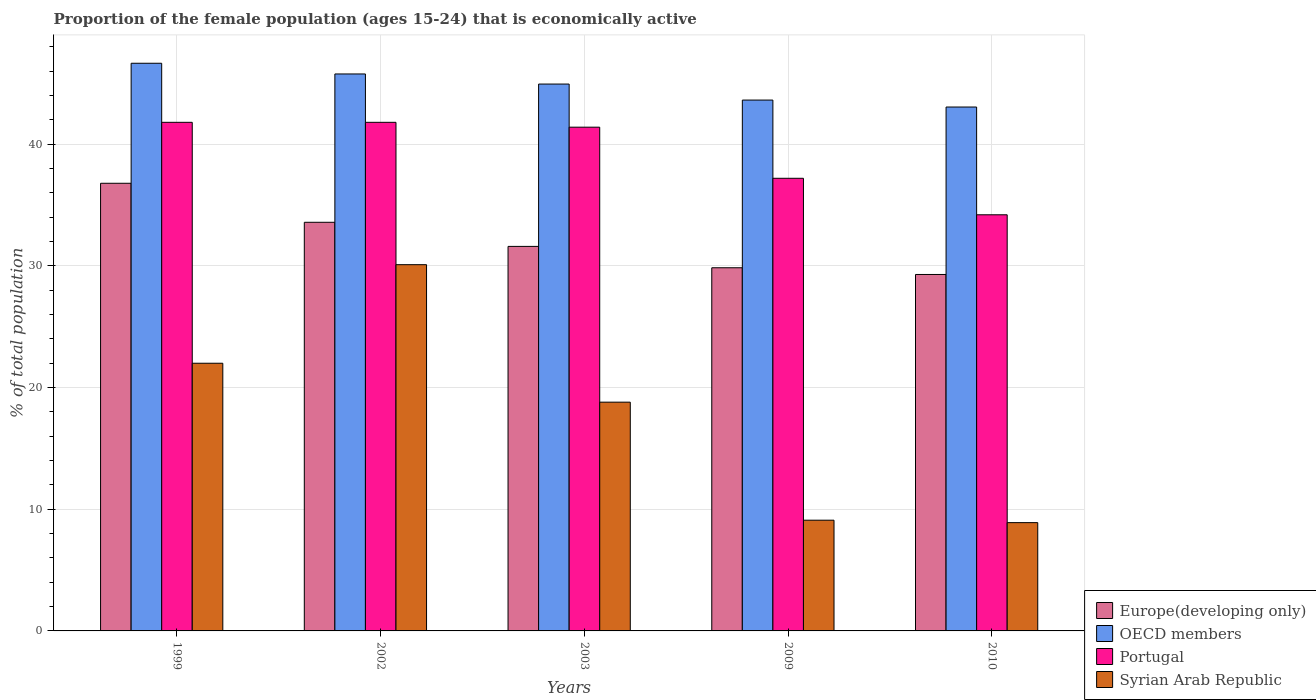How many different coloured bars are there?
Ensure brevity in your answer.  4. Are the number of bars per tick equal to the number of legend labels?
Give a very brief answer. Yes. How many bars are there on the 1st tick from the left?
Make the answer very short. 4. What is the proportion of the female population that is economically active in Syrian Arab Republic in 2003?
Your answer should be very brief. 18.8. Across all years, what is the maximum proportion of the female population that is economically active in OECD members?
Offer a terse response. 46.65. Across all years, what is the minimum proportion of the female population that is economically active in Syrian Arab Republic?
Make the answer very short. 8.9. In which year was the proportion of the female population that is economically active in Syrian Arab Republic maximum?
Your answer should be very brief. 2002. In which year was the proportion of the female population that is economically active in Europe(developing only) minimum?
Ensure brevity in your answer.  2010. What is the total proportion of the female population that is economically active in OECD members in the graph?
Offer a terse response. 224.06. What is the difference between the proportion of the female population that is economically active in OECD members in 2003 and that in 2010?
Make the answer very short. 1.89. What is the difference between the proportion of the female population that is economically active in Portugal in 2003 and the proportion of the female population that is economically active in Syrian Arab Republic in 2009?
Make the answer very short. 32.3. What is the average proportion of the female population that is economically active in OECD members per year?
Provide a succinct answer. 44.81. In the year 2003, what is the difference between the proportion of the female population that is economically active in Europe(developing only) and proportion of the female population that is economically active in OECD members?
Offer a very short reply. -13.34. What is the ratio of the proportion of the female population that is economically active in OECD members in 1999 to that in 2003?
Provide a succinct answer. 1.04. Is the difference between the proportion of the female population that is economically active in Europe(developing only) in 2002 and 2009 greater than the difference between the proportion of the female population that is economically active in OECD members in 2002 and 2009?
Ensure brevity in your answer.  Yes. What is the difference between the highest and the second highest proportion of the female population that is economically active in OECD members?
Offer a very short reply. 0.88. What is the difference between the highest and the lowest proportion of the female population that is economically active in OECD members?
Your answer should be compact. 3.6. In how many years, is the proportion of the female population that is economically active in Syrian Arab Republic greater than the average proportion of the female population that is economically active in Syrian Arab Republic taken over all years?
Provide a short and direct response. 3. What does the 4th bar from the right in 2010 represents?
Offer a very short reply. Europe(developing only). How many bars are there?
Keep it short and to the point. 20. Are all the bars in the graph horizontal?
Your answer should be compact. No. Are the values on the major ticks of Y-axis written in scientific E-notation?
Keep it short and to the point. No. What is the title of the graph?
Your answer should be compact. Proportion of the female population (ages 15-24) that is economically active. What is the label or title of the Y-axis?
Your response must be concise. % of total population. What is the % of total population of Europe(developing only) in 1999?
Give a very brief answer. 36.79. What is the % of total population of OECD members in 1999?
Keep it short and to the point. 46.65. What is the % of total population in Portugal in 1999?
Offer a terse response. 41.8. What is the % of total population in Europe(developing only) in 2002?
Ensure brevity in your answer.  33.58. What is the % of total population in OECD members in 2002?
Provide a succinct answer. 45.77. What is the % of total population in Portugal in 2002?
Provide a succinct answer. 41.8. What is the % of total population of Syrian Arab Republic in 2002?
Offer a very short reply. 30.1. What is the % of total population of Europe(developing only) in 2003?
Give a very brief answer. 31.6. What is the % of total population of OECD members in 2003?
Your answer should be compact. 44.94. What is the % of total population in Portugal in 2003?
Keep it short and to the point. 41.4. What is the % of total population of Syrian Arab Republic in 2003?
Your answer should be very brief. 18.8. What is the % of total population in Europe(developing only) in 2009?
Provide a succinct answer. 29.85. What is the % of total population in OECD members in 2009?
Keep it short and to the point. 43.63. What is the % of total population of Portugal in 2009?
Your answer should be compact. 37.2. What is the % of total population of Syrian Arab Republic in 2009?
Provide a short and direct response. 9.1. What is the % of total population in Europe(developing only) in 2010?
Keep it short and to the point. 29.29. What is the % of total population of OECD members in 2010?
Provide a short and direct response. 43.06. What is the % of total population in Portugal in 2010?
Provide a succinct answer. 34.2. What is the % of total population in Syrian Arab Republic in 2010?
Provide a short and direct response. 8.9. Across all years, what is the maximum % of total population of Europe(developing only)?
Offer a very short reply. 36.79. Across all years, what is the maximum % of total population of OECD members?
Provide a succinct answer. 46.65. Across all years, what is the maximum % of total population of Portugal?
Offer a terse response. 41.8. Across all years, what is the maximum % of total population of Syrian Arab Republic?
Make the answer very short. 30.1. Across all years, what is the minimum % of total population of Europe(developing only)?
Give a very brief answer. 29.29. Across all years, what is the minimum % of total population of OECD members?
Provide a succinct answer. 43.06. Across all years, what is the minimum % of total population in Portugal?
Provide a short and direct response. 34.2. Across all years, what is the minimum % of total population of Syrian Arab Republic?
Ensure brevity in your answer.  8.9. What is the total % of total population in Europe(developing only) in the graph?
Provide a short and direct response. 161.12. What is the total % of total population in OECD members in the graph?
Keep it short and to the point. 224.06. What is the total % of total population in Portugal in the graph?
Keep it short and to the point. 196.4. What is the total % of total population in Syrian Arab Republic in the graph?
Your answer should be compact. 88.9. What is the difference between the % of total population in Europe(developing only) in 1999 and that in 2002?
Give a very brief answer. 3.21. What is the difference between the % of total population in OECD members in 1999 and that in 2002?
Your answer should be compact. 0.88. What is the difference between the % of total population in Portugal in 1999 and that in 2002?
Your answer should be compact. 0. What is the difference between the % of total population of Syrian Arab Republic in 1999 and that in 2002?
Keep it short and to the point. -8.1. What is the difference between the % of total population of Europe(developing only) in 1999 and that in 2003?
Provide a succinct answer. 5.19. What is the difference between the % of total population in OECD members in 1999 and that in 2003?
Your response must be concise. 1.71. What is the difference between the % of total population of Europe(developing only) in 1999 and that in 2009?
Give a very brief answer. 6.94. What is the difference between the % of total population of OECD members in 1999 and that in 2009?
Make the answer very short. 3.03. What is the difference between the % of total population in Portugal in 1999 and that in 2009?
Your answer should be compact. 4.6. What is the difference between the % of total population of Europe(developing only) in 1999 and that in 2010?
Offer a terse response. 7.5. What is the difference between the % of total population of OECD members in 1999 and that in 2010?
Your answer should be very brief. 3.6. What is the difference between the % of total population in Syrian Arab Republic in 1999 and that in 2010?
Keep it short and to the point. 13.1. What is the difference between the % of total population of Europe(developing only) in 2002 and that in 2003?
Your answer should be compact. 1.98. What is the difference between the % of total population in OECD members in 2002 and that in 2003?
Your response must be concise. 0.83. What is the difference between the % of total population in Portugal in 2002 and that in 2003?
Provide a short and direct response. 0.4. What is the difference between the % of total population in Syrian Arab Republic in 2002 and that in 2003?
Offer a terse response. 11.3. What is the difference between the % of total population of Europe(developing only) in 2002 and that in 2009?
Offer a terse response. 3.74. What is the difference between the % of total population of OECD members in 2002 and that in 2009?
Keep it short and to the point. 2.15. What is the difference between the % of total population in Portugal in 2002 and that in 2009?
Your response must be concise. 4.6. What is the difference between the % of total population in Europe(developing only) in 2002 and that in 2010?
Keep it short and to the point. 4.29. What is the difference between the % of total population in OECD members in 2002 and that in 2010?
Ensure brevity in your answer.  2.72. What is the difference between the % of total population of Portugal in 2002 and that in 2010?
Make the answer very short. 7.6. What is the difference between the % of total population in Syrian Arab Republic in 2002 and that in 2010?
Your response must be concise. 21.2. What is the difference between the % of total population in Europe(developing only) in 2003 and that in 2009?
Keep it short and to the point. 1.76. What is the difference between the % of total population in OECD members in 2003 and that in 2009?
Your answer should be very brief. 1.32. What is the difference between the % of total population of Portugal in 2003 and that in 2009?
Provide a short and direct response. 4.2. What is the difference between the % of total population of Syrian Arab Republic in 2003 and that in 2009?
Give a very brief answer. 9.7. What is the difference between the % of total population in Europe(developing only) in 2003 and that in 2010?
Offer a terse response. 2.31. What is the difference between the % of total population in OECD members in 2003 and that in 2010?
Give a very brief answer. 1.89. What is the difference between the % of total population in Europe(developing only) in 2009 and that in 2010?
Keep it short and to the point. 0.55. What is the difference between the % of total population of OECD members in 2009 and that in 2010?
Your answer should be very brief. 0.57. What is the difference between the % of total population in Syrian Arab Republic in 2009 and that in 2010?
Offer a very short reply. 0.2. What is the difference between the % of total population in Europe(developing only) in 1999 and the % of total population in OECD members in 2002?
Offer a terse response. -8.98. What is the difference between the % of total population in Europe(developing only) in 1999 and the % of total population in Portugal in 2002?
Your answer should be very brief. -5.01. What is the difference between the % of total population of Europe(developing only) in 1999 and the % of total population of Syrian Arab Republic in 2002?
Provide a succinct answer. 6.69. What is the difference between the % of total population in OECD members in 1999 and the % of total population in Portugal in 2002?
Your answer should be very brief. 4.85. What is the difference between the % of total population of OECD members in 1999 and the % of total population of Syrian Arab Republic in 2002?
Keep it short and to the point. 16.55. What is the difference between the % of total population of Europe(developing only) in 1999 and the % of total population of OECD members in 2003?
Your answer should be very brief. -8.15. What is the difference between the % of total population in Europe(developing only) in 1999 and the % of total population in Portugal in 2003?
Give a very brief answer. -4.61. What is the difference between the % of total population of Europe(developing only) in 1999 and the % of total population of Syrian Arab Republic in 2003?
Your response must be concise. 17.99. What is the difference between the % of total population in OECD members in 1999 and the % of total population in Portugal in 2003?
Make the answer very short. 5.25. What is the difference between the % of total population in OECD members in 1999 and the % of total population in Syrian Arab Republic in 2003?
Your answer should be compact. 27.85. What is the difference between the % of total population of Europe(developing only) in 1999 and the % of total population of OECD members in 2009?
Give a very brief answer. -6.84. What is the difference between the % of total population of Europe(developing only) in 1999 and the % of total population of Portugal in 2009?
Your answer should be very brief. -0.41. What is the difference between the % of total population of Europe(developing only) in 1999 and the % of total population of Syrian Arab Republic in 2009?
Offer a terse response. 27.69. What is the difference between the % of total population of OECD members in 1999 and the % of total population of Portugal in 2009?
Your answer should be compact. 9.45. What is the difference between the % of total population in OECD members in 1999 and the % of total population in Syrian Arab Republic in 2009?
Give a very brief answer. 37.55. What is the difference between the % of total population in Portugal in 1999 and the % of total population in Syrian Arab Republic in 2009?
Offer a terse response. 32.7. What is the difference between the % of total population in Europe(developing only) in 1999 and the % of total population in OECD members in 2010?
Make the answer very short. -6.27. What is the difference between the % of total population in Europe(developing only) in 1999 and the % of total population in Portugal in 2010?
Your response must be concise. 2.59. What is the difference between the % of total population of Europe(developing only) in 1999 and the % of total population of Syrian Arab Republic in 2010?
Make the answer very short. 27.89. What is the difference between the % of total population in OECD members in 1999 and the % of total population in Portugal in 2010?
Your answer should be compact. 12.45. What is the difference between the % of total population in OECD members in 1999 and the % of total population in Syrian Arab Republic in 2010?
Provide a succinct answer. 37.75. What is the difference between the % of total population of Portugal in 1999 and the % of total population of Syrian Arab Republic in 2010?
Your response must be concise. 32.9. What is the difference between the % of total population in Europe(developing only) in 2002 and the % of total population in OECD members in 2003?
Ensure brevity in your answer.  -11.36. What is the difference between the % of total population of Europe(developing only) in 2002 and the % of total population of Portugal in 2003?
Make the answer very short. -7.82. What is the difference between the % of total population in Europe(developing only) in 2002 and the % of total population in Syrian Arab Republic in 2003?
Offer a very short reply. 14.78. What is the difference between the % of total population of OECD members in 2002 and the % of total population of Portugal in 2003?
Your response must be concise. 4.37. What is the difference between the % of total population in OECD members in 2002 and the % of total population in Syrian Arab Republic in 2003?
Ensure brevity in your answer.  26.97. What is the difference between the % of total population of Portugal in 2002 and the % of total population of Syrian Arab Republic in 2003?
Your answer should be very brief. 23. What is the difference between the % of total population of Europe(developing only) in 2002 and the % of total population of OECD members in 2009?
Offer a terse response. -10.04. What is the difference between the % of total population in Europe(developing only) in 2002 and the % of total population in Portugal in 2009?
Your response must be concise. -3.62. What is the difference between the % of total population of Europe(developing only) in 2002 and the % of total population of Syrian Arab Republic in 2009?
Ensure brevity in your answer.  24.48. What is the difference between the % of total population of OECD members in 2002 and the % of total population of Portugal in 2009?
Offer a terse response. 8.57. What is the difference between the % of total population in OECD members in 2002 and the % of total population in Syrian Arab Republic in 2009?
Give a very brief answer. 36.67. What is the difference between the % of total population in Portugal in 2002 and the % of total population in Syrian Arab Republic in 2009?
Your answer should be very brief. 32.7. What is the difference between the % of total population of Europe(developing only) in 2002 and the % of total population of OECD members in 2010?
Ensure brevity in your answer.  -9.47. What is the difference between the % of total population of Europe(developing only) in 2002 and the % of total population of Portugal in 2010?
Your response must be concise. -0.62. What is the difference between the % of total population of Europe(developing only) in 2002 and the % of total population of Syrian Arab Republic in 2010?
Make the answer very short. 24.68. What is the difference between the % of total population in OECD members in 2002 and the % of total population in Portugal in 2010?
Keep it short and to the point. 11.57. What is the difference between the % of total population of OECD members in 2002 and the % of total population of Syrian Arab Republic in 2010?
Your answer should be compact. 36.87. What is the difference between the % of total population in Portugal in 2002 and the % of total population in Syrian Arab Republic in 2010?
Offer a terse response. 32.9. What is the difference between the % of total population in Europe(developing only) in 2003 and the % of total population in OECD members in 2009?
Give a very brief answer. -12.03. What is the difference between the % of total population of Europe(developing only) in 2003 and the % of total population of Portugal in 2009?
Offer a terse response. -5.6. What is the difference between the % of total population of Europe(developing only) in 2003 and the % of total population of Syrian Arab Republic in 2009?
Provide a succinct answer. 22.5. What is the difference between the % of total population of OECD members in 2003 and the % of total population of Portugal in 2009?
Your answer should be very brief. 7.74. What is the difference between the % of total population of OECD members in 2003 and the % of total population of Syrian Arab Republic in 2009?
Provide a succinct answer. 35.84. What is the difference between the % of total population of Portugal in 2003 and the % of total population of Syrian Arab Republic in 2009?
Give a very brief answer. 32.3. What is the difference between the % of total population of Europe(developing only) in 2003 and the % of total population of OECD members in 2010?
Ensure brevity in your answer.  -11.45. What is the difference between the % of total population in Europe(developing only) in 2003 and the % of total population in Portugal in 2010?
Ensure brevity in your answer.  -2.6. What is the difference between the % of total population in Europe(developing only) in 2003 and the % of total population in Syrian Arab Republic in 2010?
Offer a terse response. 22.7. What is the difference between the % of total population of OECD members in 2003 and the % of total population of Portugal in 2010?
Make the answer very short. 10.74. What is the difference between the % of total population in OECD members in 2003 and the % of total population in Syrian Arab Republic in 2010?
Offer a terse response. 36.04. What is the difference between the % of total population in Portugal in 2003 and the % of total population in Syrian Arab Republic in 2010?
Keep it short and to the point. 32.5. What is the difference between the % of total population in Europe(developing only) in 2009 and the % of total population in OECD members in 2010?
Provide a succinct answer. -13.21. What is the difference between the % of total population in Europe(developing only) in 2009 and the % of total population in Portugal in 2010?
Make the answer very short. -4.35. What is the difference between the % of total population in Europe(developing only) in 2009 and the % of total population in Syrian Arab Republic in 2010?
Offer a terse response. 20.95. What is the difference between the % of total population of OECD members in 2009 and the % of total population of Portugal in 2010?
Offer a terse response. 9.43. What is the difference between the % of total population in OECD members in 2009 and the % of total population in Syrian Arab Republic in 2010?
Keep it short and to the point. 34.73. What is the difference between the % of total population of Portugal in 2009 and the % of total population of Syrian Arab Republic in 2010?
Ensure brevity in your answer.  28.3. What is the average % of total population of Europe(developing only) per year?
Your response must be concise. 32.22. What is the average % of total population of OECD members per year?
Your answer should be very brief. 44.81. What is the average % of total population in Portugal per year?
Keep it short and to the point. 39.28. What is the average % of total population in Syrian Arab Republic per year?
Offer a terse response. 17.78. In the year 1999, what is the difference between the % of total population of Europe(developing only) and % of total population of OECD members?
Give a very brief answer. -9.86. In the year 1999, what is the difference between the % of total population of Europe(developing only) and % of total population of Portugal?
Your answer should be compact. -5.01. In the year 1999, what is the difference between the % of total population of Europe(developing only) and % of total population of Syrian Arab Republic?
Give a very brief answer. 14.79. In the year 1999, what is the difference between the % of total population of OECD members and % of total population of Portugal?
Your response must be concise. 4.85. In the year 1999, what is the difference between the % of total population of OECD members and % of total population of Syrian Arab Republic?
Ensure brevity in your answer.  24.65. In the year 1999, what is the difference between the % of total population in Portugal and % of total population in Syrian Arab Republic?
Offer a very short reply. 19.8. In the year 2002, what is the difference between the % of total population of Europe(developing only) and % of total population of OECD members?
Offer a very short reply. -12.19. In the year 2002, what is the difference between the % of total population of Europe(developing only) and % of total population of Portugal?
Offer a terse response. -8.22. In the year 2002, what is the difference between the % of total population in Europe(developing only) and % of total population in Syrian Arab Republic?
Provide a short and direct response. 3.48. In the year 2002, what is the difference between the % of total population in OECD members and % of total population in Portugal?
Provide a succinct answer. 3.97. In the year 2002, what is the difference between the % of total population in OECD members and % of total population in Syrian Arab Republic?
Ensure brevity in your answer.  15.67. In the year 2002, what is the difference between the % of total population of Portugal and % of total population of Syrian Arab Republic?
Provide a short and direct response. 11.7. In the year 2003, what is the difference between the % of total population of Europe(developing only) and % of total population of OECD members?
Give a very brief answer. -13.34. In the year 2003, what is the difference between the % of total population in Europe(developing only) and % of total population in Portugal?
Offer a terse response. -9.8. In the year 2003, what is the difference between the % of total population of Europe(developing only) and % of total population of Syrian Arab Republic?
Your answer should be very brief. 12.8. In the year 2003, what is the difference between the % of total population in OECD members and % of total population in Portugal?
Provide a short and direct response. 3.54. In the year 2003, what is the difference between the % of total population in OECD members and % of total population in Syrian Arab Republic?
Offer a very short reply. 26.14. In the year 2003, what is the difference between the % of total population in Portugal and % of total population in Syrian Arab Republic?
Offer a terse response. 22.6. In the year 2009, what is the difference between the % of total population of Europe(developing only) and % of total population of OECD members?
Provide a succinct answer. -13.78. In the year 2009, what is the difference between the % of total population in Europe(developing only) and % of total population in Portugal?
Keep it short and to the point. -7.35. In the year 2009, what is the difference between the % of total population of Europe(developing only) and % of total population of Syrian Arab Republic?
Ensure brevity in your answer.  20.75. In the year 2009, what is the difference between the % of total population of OECD members and % of total population of Portugal?
Offer a terse response. 6.43. In the year 2009, what is the difference between the % of total population in OECD members and % of total population in Syrian Arab Republic?
Your answer should be very brief. 34.53. In the year 2009, what is the difference between the % of total population in Portugal and % of total population in Syrian Arab Republic?
Offer a terse response. 28.1. In the year 2010, what is the difference between the % of total population of Europe(developing only) and % of total population of OECD members?
Provide a succinct answer. -13.76. In the year 2010, what is the difference between the % of total population in Europe(developing only) and % of total population in Portugal?
Make the answer very short. -4.91. In the year 2010, what is the difference between the % of total population of Europe(developing only) and % of total population of Syrian Arab Republic?
Offer a very short reply. 20.39. In the year 2010, what is the difference between the % of total population in OECD members and % of total population in Portugal?
Ensure brevity in your answer.  8.86. In the year 2010, what is the difference between the % of total population in OECD members and % of total population in Syrian Arab Republic?
Provide a short and direct response. 34.16. In the year 2010, what is the difference between the % of total population of Portugal and % of total population of Syrian Arab Republic?
Ensure brevity in your answer.  25.3. What is the ratio of the % of total population in Europe(developing only) in 1999 to that in 2002?
Make the answer very short. 1.1. What is the ratio of the % of total population of OECD members in 1999 to that in 2002?
Offer a very short reply. 1.02. What is the ratio of the % of total population in Syrian Arab Republic in 1999 to that in 2002?
Your answer should be compact. 0.73. What is the ratio of the % of total population in Europe(developing only) in 1999 to that in 2003?
Offer a terse response. 1.16. What is the ratio of the % of total population in OECD members in 1999 to that in 2003?
Provide a short and direct response. 1.04. What is the ratio of the % of total population of Portugal in 1999 to that in 2003?
Your response must be concise. 1.01. What is the ratio of the % of total population in Syrian Arab Republic in 1999 to that in 2003?
Keep it short and to the point. 1.17. What is the ratio of the % of total population in Europe(developing only) in 1999 to that in 2009?
Your answer should be very brief. 1.23. What is the ratio of the % of total population of OECD members in 1999 to that in 2009?
Your answer should be very brief. 1.07. What is the ratio of the % of total population of Portugal in 1999 to that in 2009?
Your response must be concise. 1.12. What is the ratio of the % of total population in Syrian Arab Republic in 1999 to that in 2009?
Make the answer very short. 2.42. What is the ratio of the % of total population in Europe(developing only) in 1999 to that in 2010?
Offer a very short reply. 1.26. What is the ratio of the % of total population of OECD members in 1999 to that in 2010?
Offer a terse response. 1.08. What is the ratio of the % of total population of Portugal in 1999 to that in 2010?
Ensure brevity in your answer.  1.22. What is the ratio of the % of total population of Syrian Arab Republic in 1999 to that in 2010?
Offer a terse response. 2.47. What is the ratio of the % of total population in Europe(developing only) in 2002 to that in 2003?
Your answer should be very brief. 1.06. What is the ratio of the % of total population in OECD members in 2002 to that in 2003?
Keep it short and to the point. 1.02. What is the ratio of the % of total population in Portugal in 2002 to that in 2003?
Your response must be concise. 1.01. What is the ratio of the % of total population of Syrian Arab Republic in 2002 to that in 2003?
Provide a succinct answer. 1.6. What is the ratio of the % of total population in Europe(developing only) in 2002 to that in 2009?
Your answer should be compact. 1.13. What is the ratio of the % of total population in OECD members in 2002 to that in 2009?
Offer a very short reply. 1.05. What is the ratio of the % of total population in Portugal in 2002 to that in 2009?
Offer a very short reply. 1.12. What is the ratio of the % of total population in Syrian Arab Republic in 2002 to that in 2009?
Your answer should be compact. 3.31. What is the ratio of the % of total population of Europe(developing only) in 2002 to that in 2010?
Make the answer very short. 1.15. What is the ratio of the % of total population in OECD members in 2002 to that in 2010?
Provide a succinct answer. 1.06. What is the ratio of the % of total population of Portugal in 2002 to that in 2010?
Offer a terse response. 1.22. What is the ratio of the % of total population of Syrian Arab Republic in 2002 to that in 2010?
Give a very brief answer. 3.38. What is the ratio of the % of total population in Europe(developing only) in 2003 to that in 2009?
Ensure brevity in your answer.  1.06. What is the ratio of the % of total population in OECD members in 2003 to that in 2009?
Ensure brevity in your answer.  1.03. What is the ratio of the % of total population of Portugal in 2003 to that in 2009?
Offer a terse response. 1.11. What is the ratio of the % of total population in Syrian Arab Republic in 2003 to that in 2009?
Provide a short and direct response. 2.07. What is the ratio of the % of total population of Europe(developing only) in 2003 to that in 2010?
Ensure brevity in your answer.  1.08. What is the ratio of the % of total population of OECD members in 2003 to that in 2010?
Make the answer very short. 1.04. What is the ratio of the % of total population in Portugal in 2003 to that in 2010?
Provide a succinct answer. 1.21. What is the ratio of the % of total population of Syrian Arab Republic in 2003 to that in 2010?
Provide a short and direct response. 2.11. What is the ratio of the % of total population in Europe(developing only) in 2009 to that in 2010?
Give a very brief answer. 1.02. What is the ratio of the % of total population in OECD members in 2009 to that in 2010?
Provide a succinct answer. 1.01. What is the ratio of the % of total population in Portugal in 2009 to that in 2010?
Keep it short and to the point. 1.09. What is the ratio of the % of total population of Syrian Arab Republic in 2009 to that in 2010?
Keep it short and to the point. 1.02. What is the difference between the highest and the second highest % of total population in Europe(developing only)?
Your answer should be very brief. 3.21. What is the difference between the highest and the second highest % of total population in OECD members?
Your response must be concise. 0.88. What is the difference between the highest and the second highest % of total population of Portugal?
Provide a short and direct response. 0. What is the difference between the highest and the second highest % of total population in Syrian Arab Republic?
Your answer should be very brief. 8.1. What is the difference between the highest and the lowest % of total population in Europe(developing only)?
Offer a very short reply. 7.5. What is the difference between the highest and the lowest % of total population in OECD members?
Your answer should be compact. 3.6. What is the difference between the highest and the lowest % of total population of Syrian Arab Republic?
Ensure brevity in your answer.  21.2. 